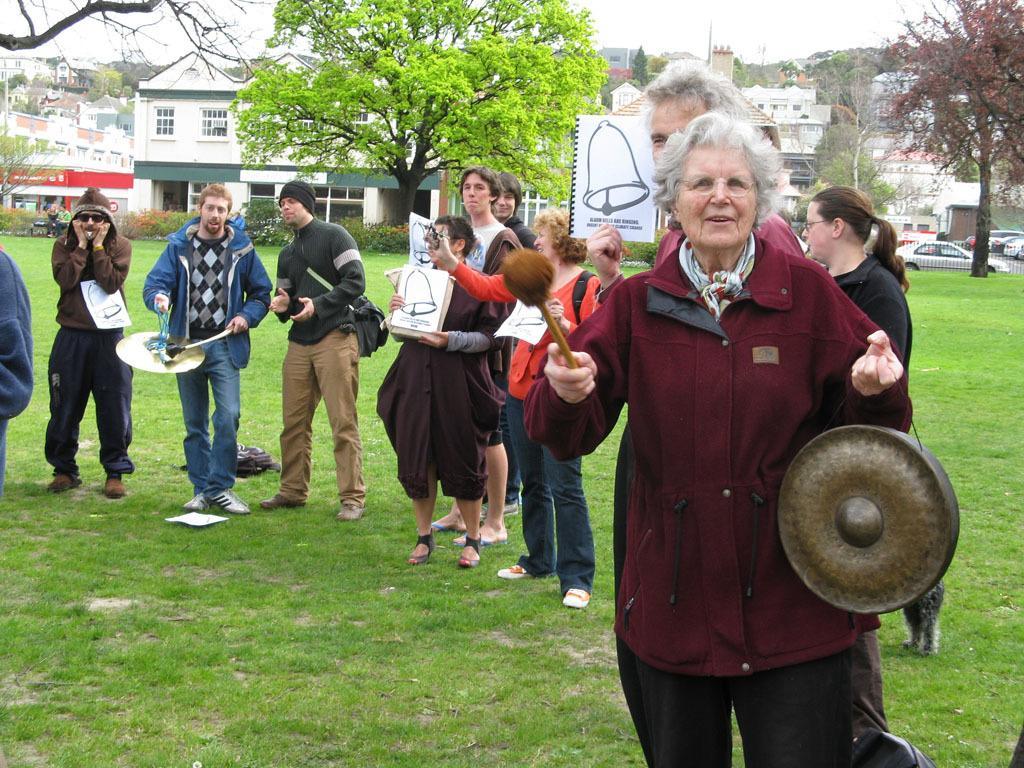Can you describe this image briefly? On the right side an old woman is standing, she wore a dark red color. In the middle there is a green tree, behind it there are buildings. 